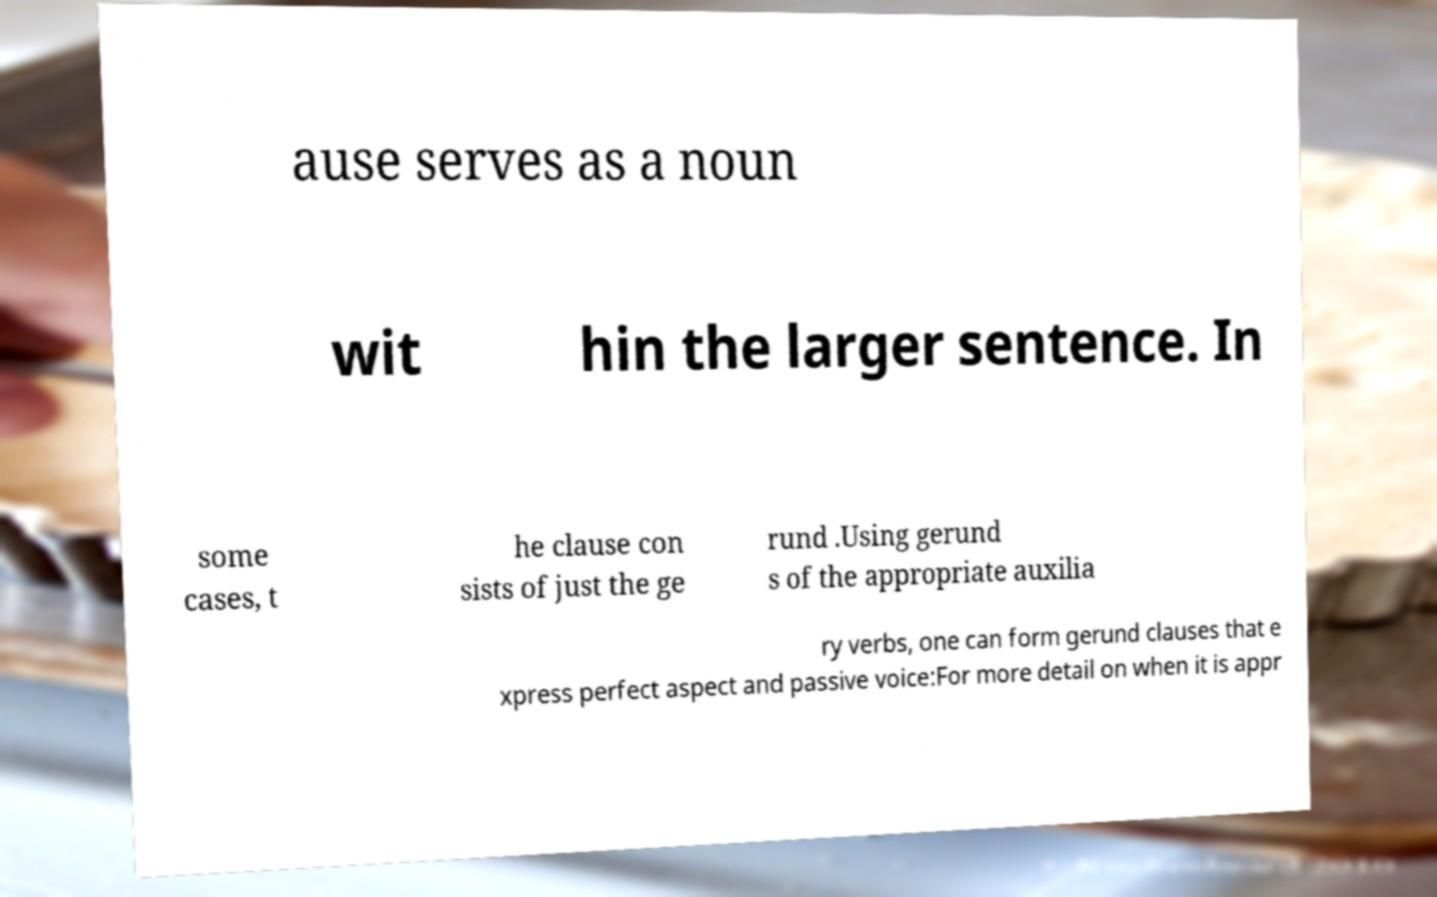I need the written content from this picture converted into text. Can you do that? ause serves as a noun wit hin the larger sentence. In some cases, t he clause con sists of just the ge rund .Using gerund s of the appropriate auxilia ry verbs, one can form gerund clauses that e xpress perfect aspect and passive voice:For more detail on when it is appr 